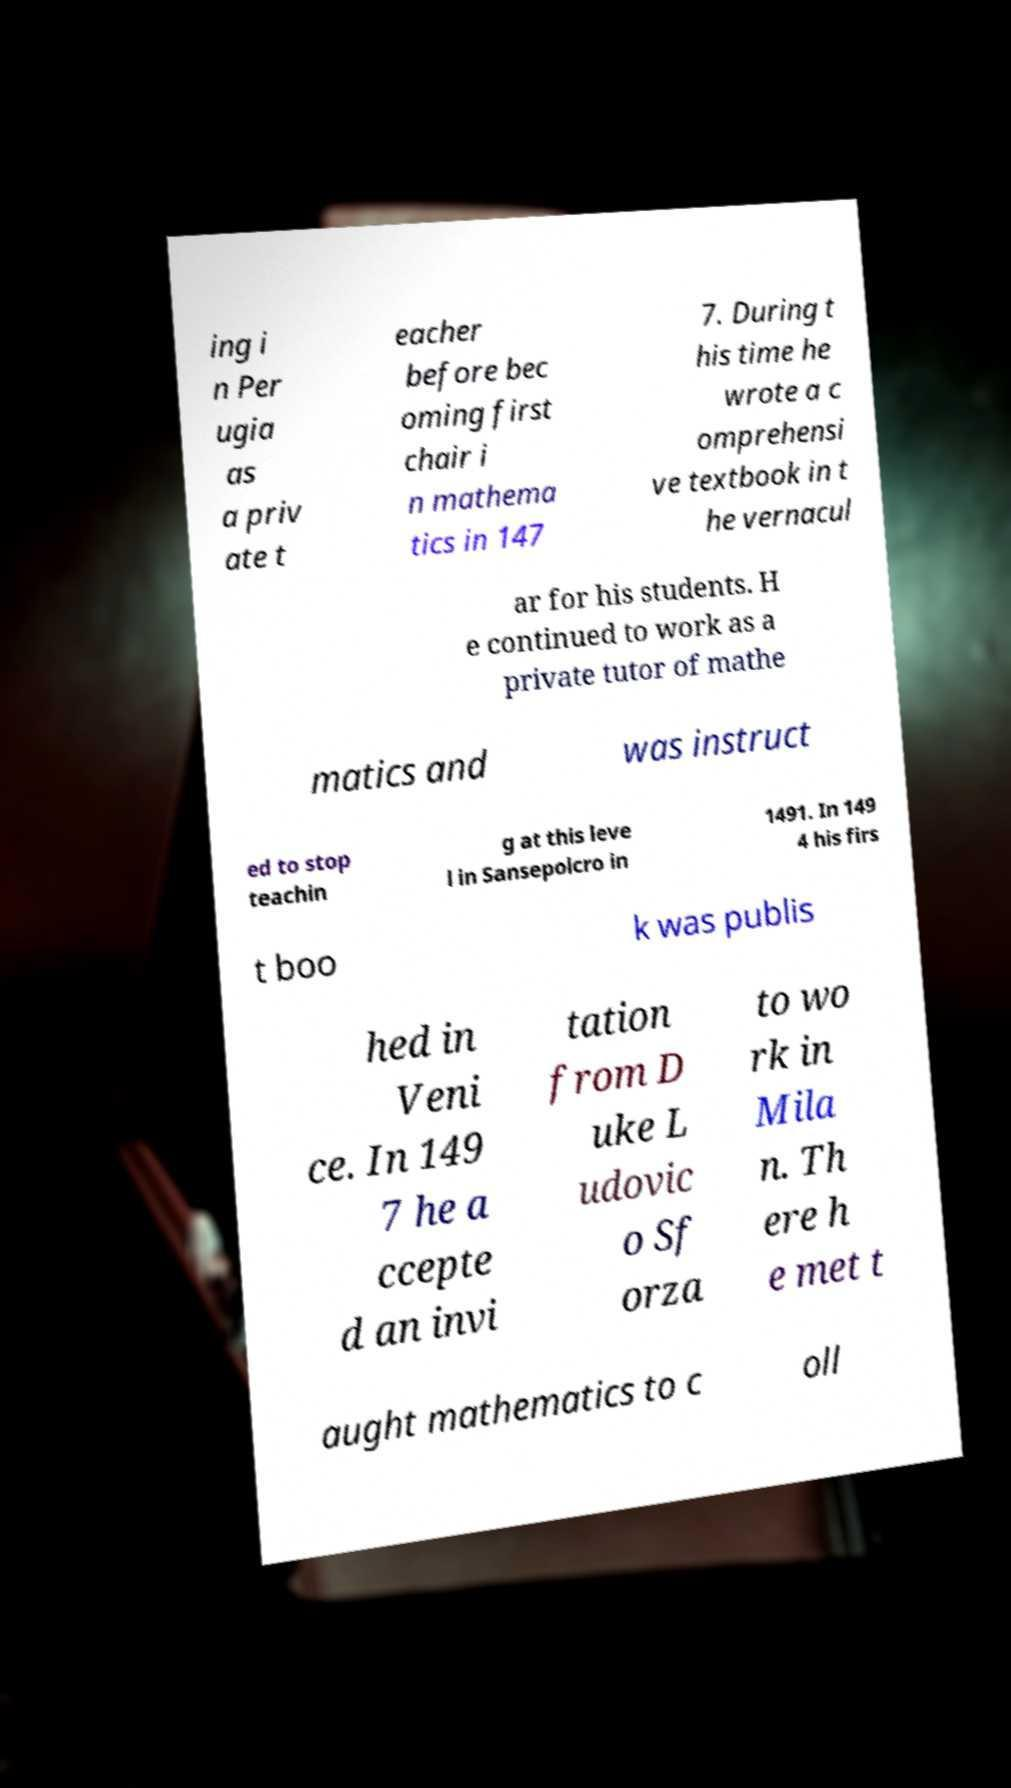Can you read and provide the text displayed in the image?This photo seems to have some interesting text. Can you extract and type it out for me? ing i n Per ugia as a priv ate t eacher before bec oming first chair i n mathema tics in 147 7. During t his time he wrote a c omprehensi ve textbook in t he vernacul ar for his students. H e continued to work as a private tutor of mathe matics and was instruct ed to stop teachin g at this leve l in Sansepolcro in 1491. In 149 4 his firs t boo k was publis hed in Veni ce. In 149 7 he a ccepte d an invi tation from D uke L udovic o Sf orza to wo rk in Mila n. Th ere h e met t aught mathematics to c oll 